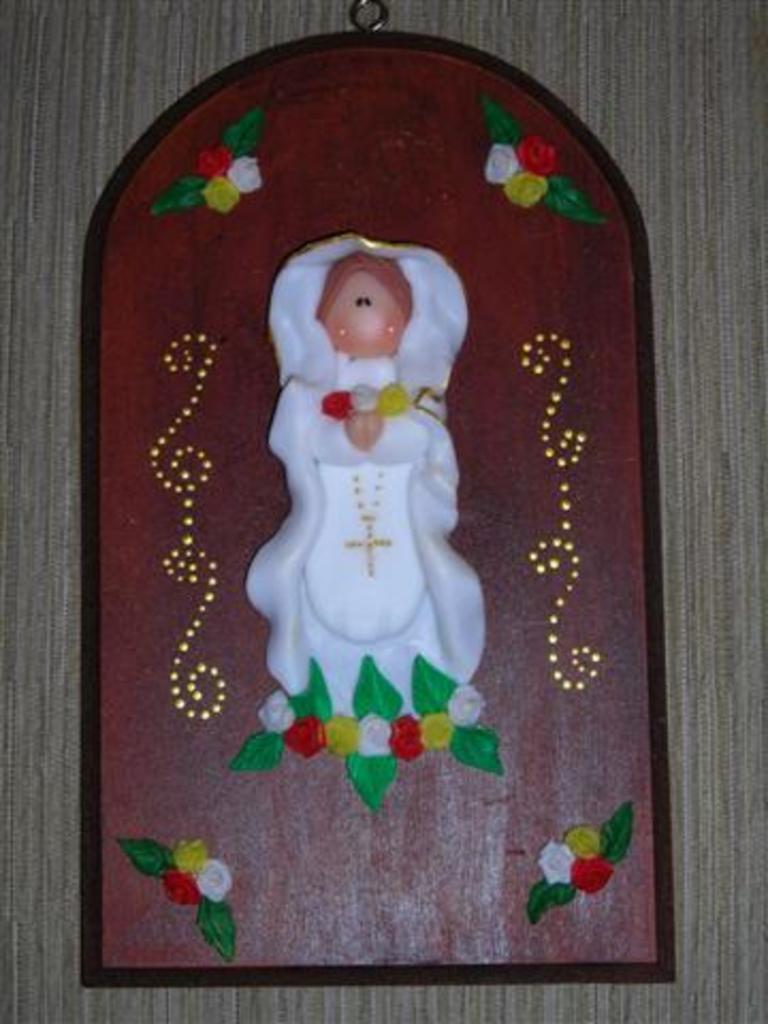What is hanging on the wall in the image? There is a frame hanging on the wall in the image. What type of knife is being used to tell a story in the image? There is no knife or storytelling depicted in the image; it only features a frame hanging on the wall. 